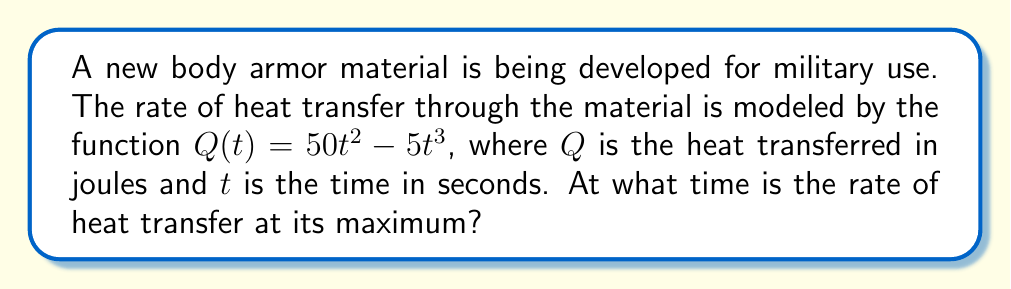Provide a solution to this math problem. To find the maximum rate of heat transfer, we need to follow these steps:

1) The rate of heat transfer is given by the derivative of $Q(t)$ with respect to $t$. Let's call this $Q'(t)$.

2) Calculate $Q'(t)$:
   $$Q'(t) = \frac{d}{dt}(50t^2 - 5t^3) = 100t - 15t^2$$

3) To find the maximum rate, we need to find where the derivative of $Q'(t)$ equals zero. Let's call this second derivative $Q''(t)$.

4) Calculate $Q''(t)$:
   $$Q''(t) = \frac{d}{dt}(100t - 15t^2) = 100 - 30t$$

5) Set $Q''(t) = 0$ and solve for $t$:
   $$100 - 30t = 0$$
   $$-30t = -100$$
   $$t = \frac{10}{3} \approx 3.33 \text{ seconds}$$

6) To confirm this is a maximum (not a minimum), we can check that $Q''(t)$ is negative at this point:
   $$Q''(\frac{10}{3}) = 100 - 30(\frac{10}{3}) = 100 - 100 = 0$$
   
   Since $Q''(t)$ changes from positive to negative at $t = \frac{10}{3}$, this confirms it's a maximum.

Therefore, the rate of heat transfer is at its maximum when $t = \frac{10}{3}$ seconds.
Answer: $\frac{10}{3}$ seconds 